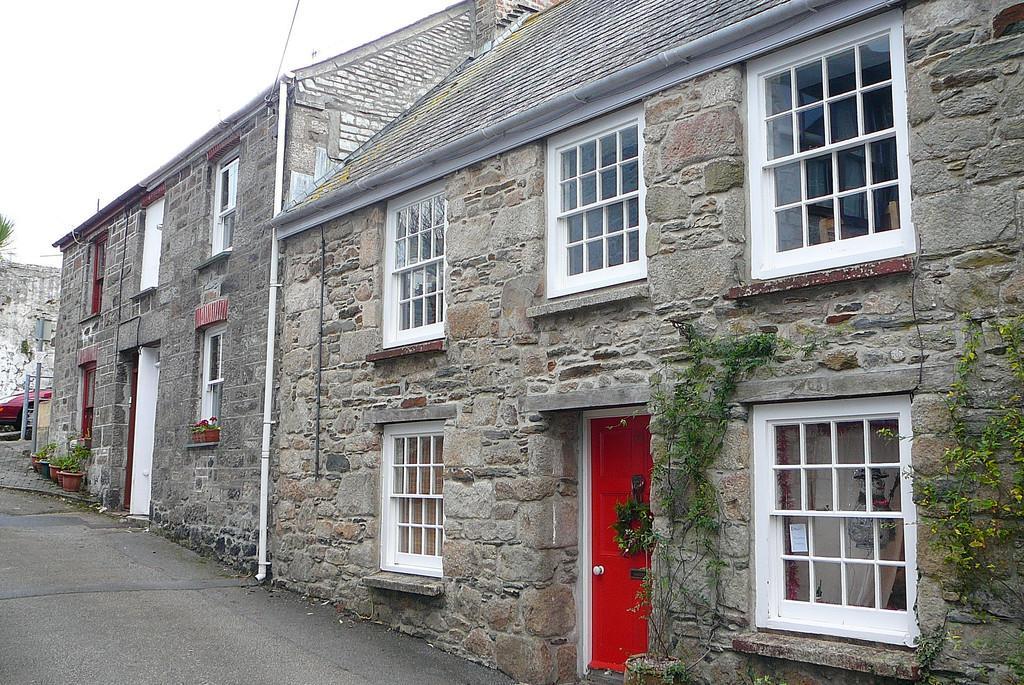In one or two sentences, can you explain what this image depicts? In this image there are houses, a tree, a vehicle, there are plants, and in the background there is sky. 